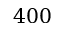Convert formula to latex. <formula><loc_0><loc_0><loc_500><loc_500>4 0 0</formula> 